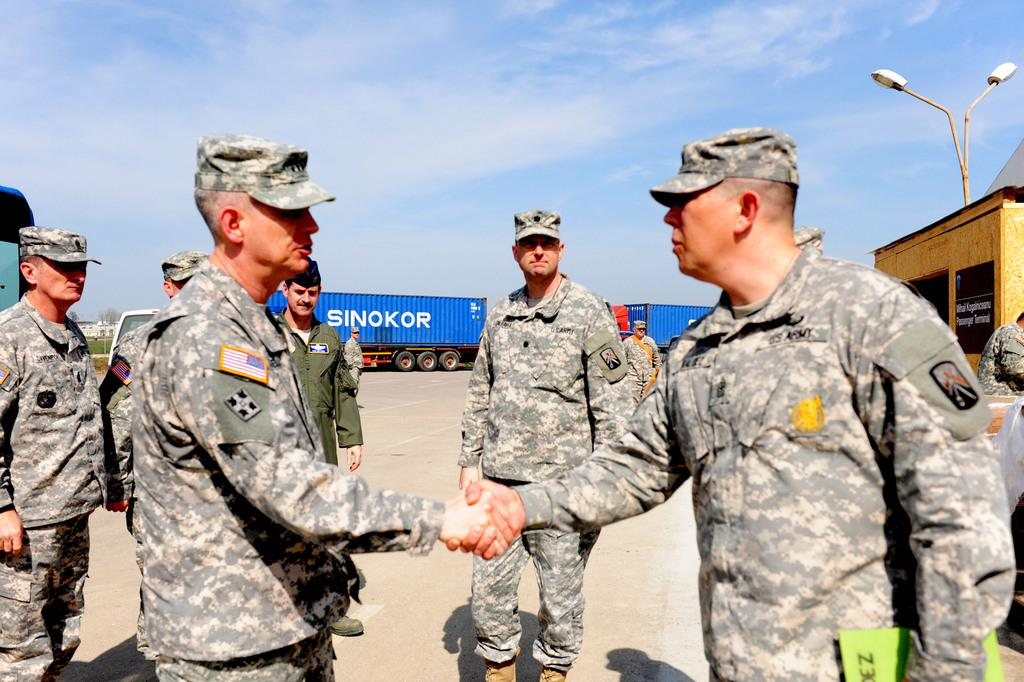What is the main subject of the image? The main subject of the image is a group of people. What can be seen in the background of the image? There are containers and the sky visible in the background of the image. How many plates are visible on the table in the image? There is no table or plate present in the image; it features a group of people and containers in the background. 